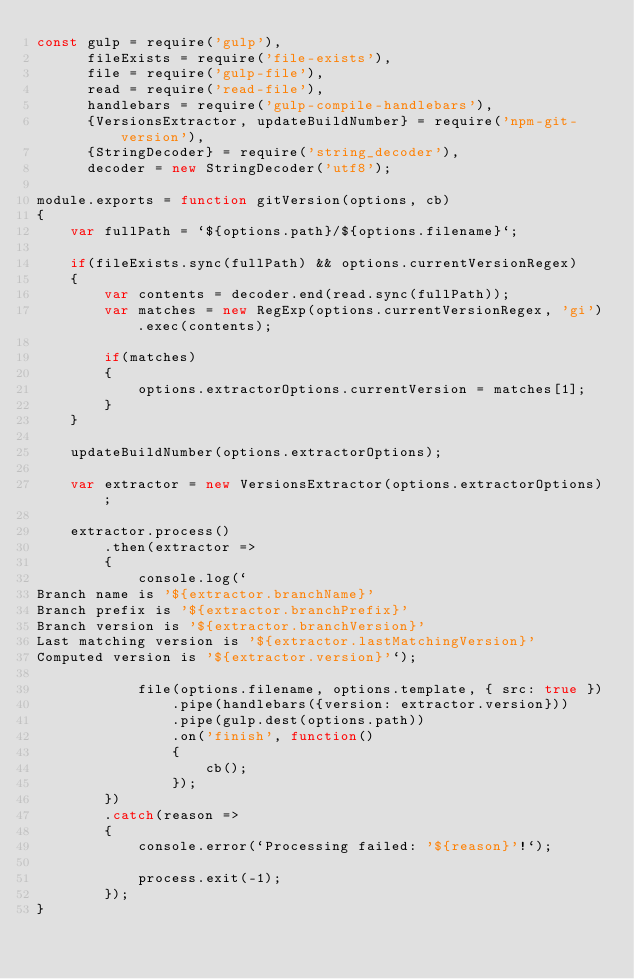Convert code to text. <code><loc_0><loc_0><loc_500><loc_500><_JavaScript_>const gulp = require('gulp'),
      fileExists = require('file-exists'),
      file = require('gulp-file'),
      read = require('read-file'),
      handlebars = require('gulp-compile-handlebars'),
      {VersionsExtractor, updateBuildNumber} = require('npm-git-version'),
      {StringDecoder} = require('string_decoder'),
      decoder = new StringDecoder('utf8');

module.exports = function gitVersion(options, cb)
{
    var fullPath = `${options.path}/${options.filename}`;

    if(fileExists.sync(fullPath) && options.currentVersionRegex)
    {
        var contents = decoder.end(read.sync(fullPath));
        var matches = new RegExp(options.currentVersionRegex, 'gi').exec(contents);

        if(matches)
        {
            options.extractorOptions.currentVersion = matches[1];
        }
    }

    updateBuildNumber(options.extractorOptions);

    var extractor = new VersionsExtractor(options.extractorOptions);

    extractor.process()
        .then(extractor =>
        {
            console.log(`
Branch name is '${extractor.branchName}'
Branch prefix is '${extractor.branchPrefix}'
Branch version is '${extractor.branchVersion}'
Last matching version is '${extractor.lastMatchingVersion}'
Computed version is '${extractor.version}'`);

            file(options.filename, options.template, { src: true })
                .pipe(handlebars({version: extractor.version}))
                .pipe(gulp.dest(options.path))
                .on('finish', function()
                {
                    cb();
                });
        })
        .catch(reason =>
        {
            console.error(`Processing failed: '${reason}'!`);

            process.exit(-1);
        });
}</code> 